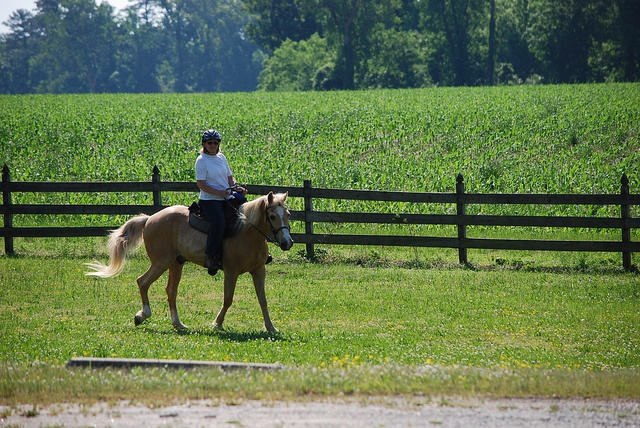Describe the objects in this image and their specific colors. I can see horse in lavender, black, gray, olive, and darkgreen tones and people in lavender, black, and gray tones in this image. 